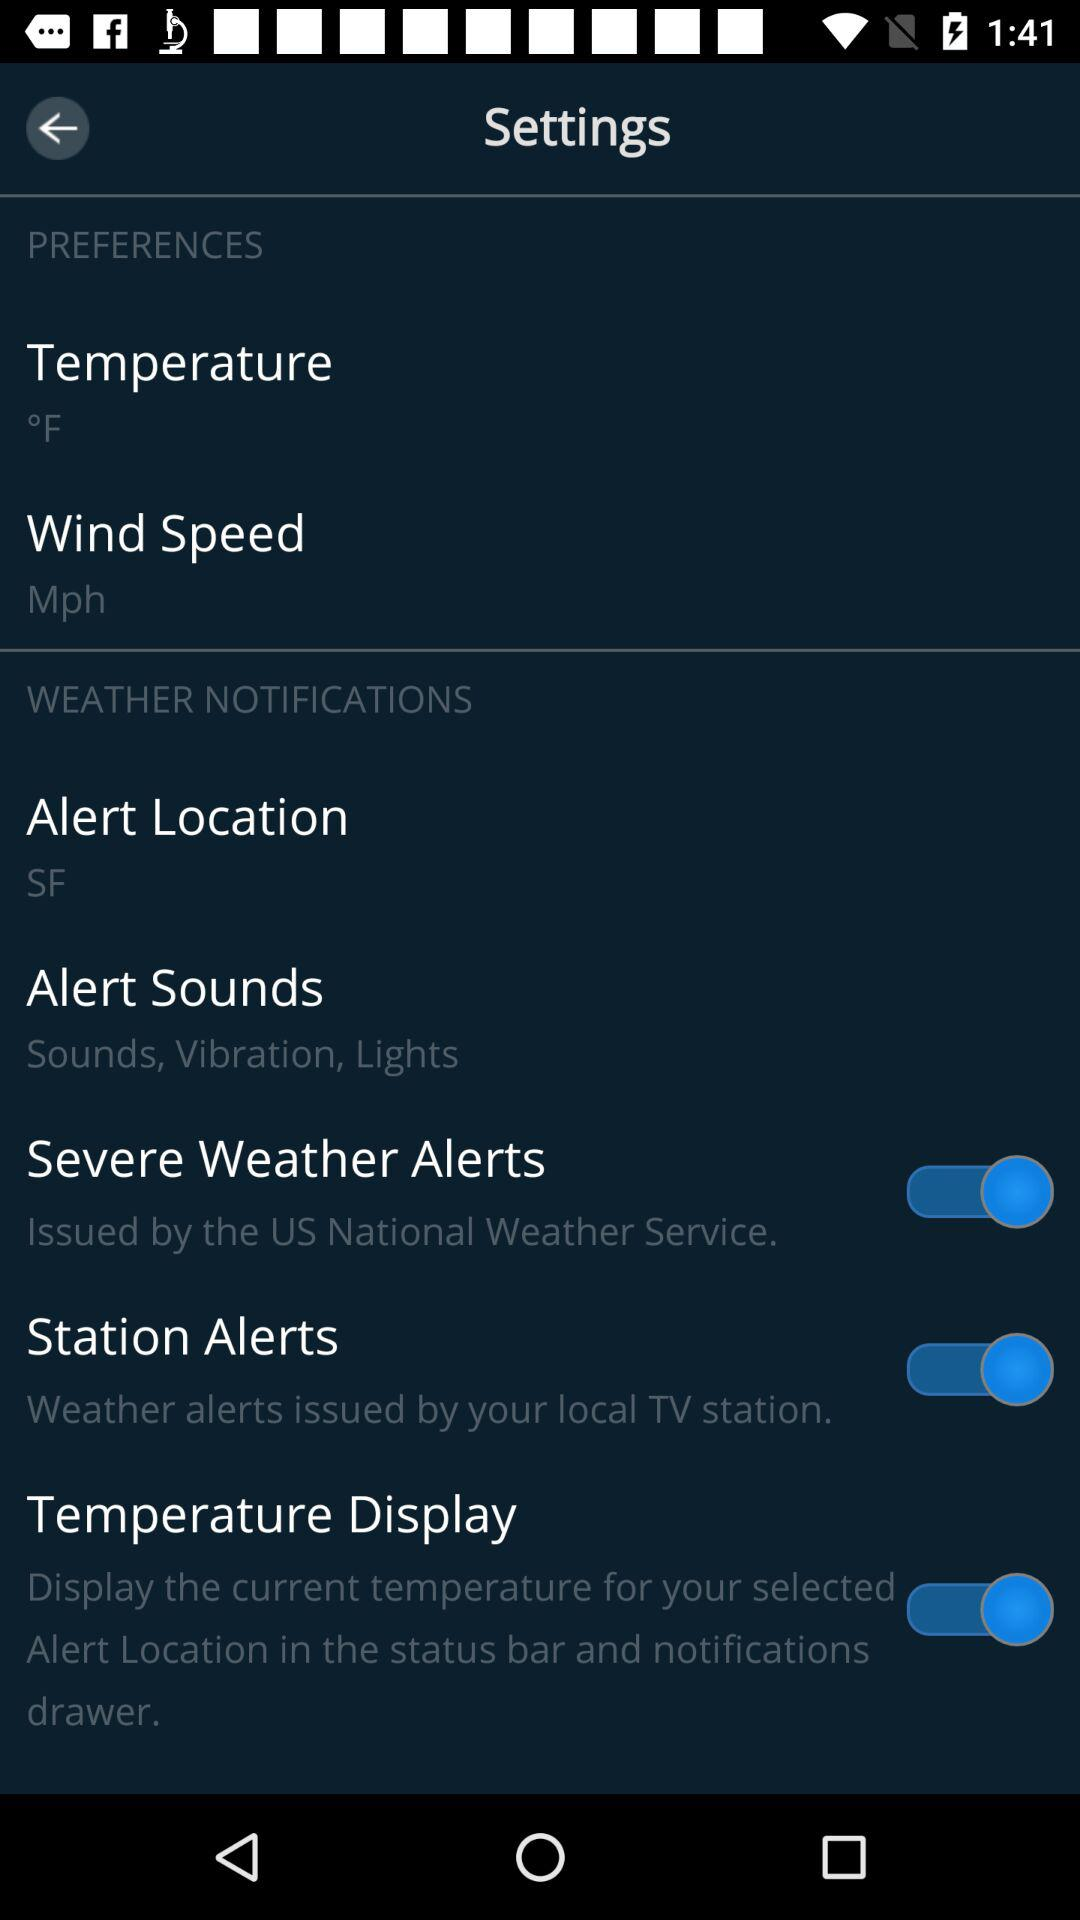How many items in the 'Weather Notifications' section have a switch?
Answer the question using a single word or phrase. 3 